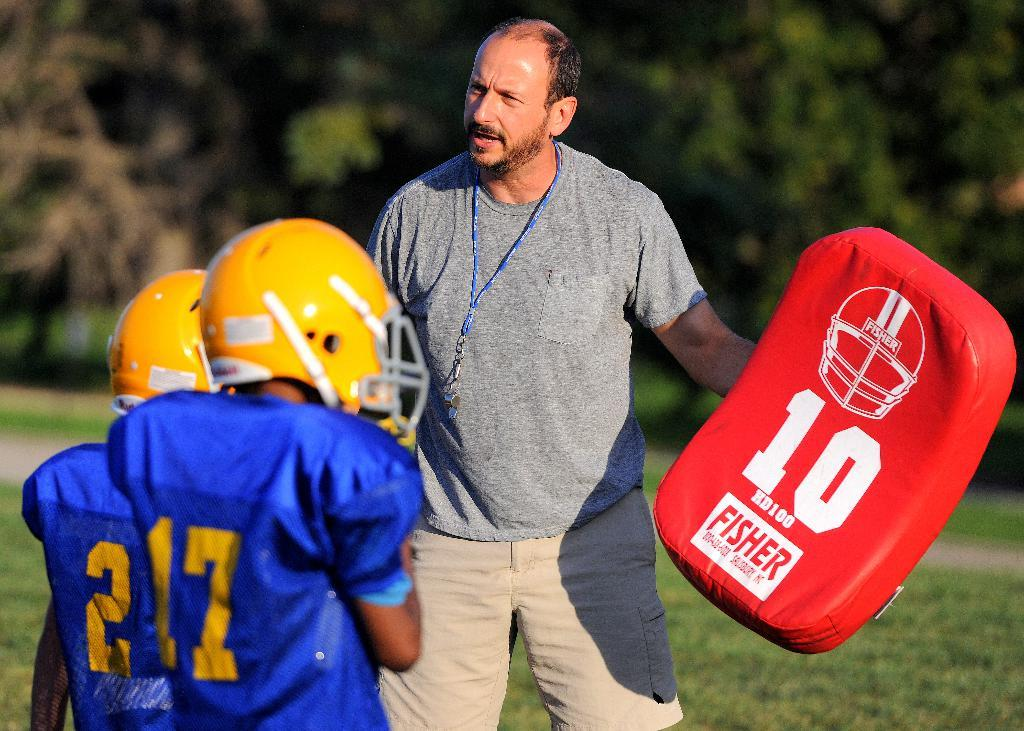What is the main subject of the image? There is a man in the middle of the image. What is the man holding in his hand? The man is holding a red object in his hand. Can you describe the other people in the image? There are two players on the left side of the image. What is the weight of the clocks in the image? There are no clocks present in the image, so it is not possible to determine their weight. 